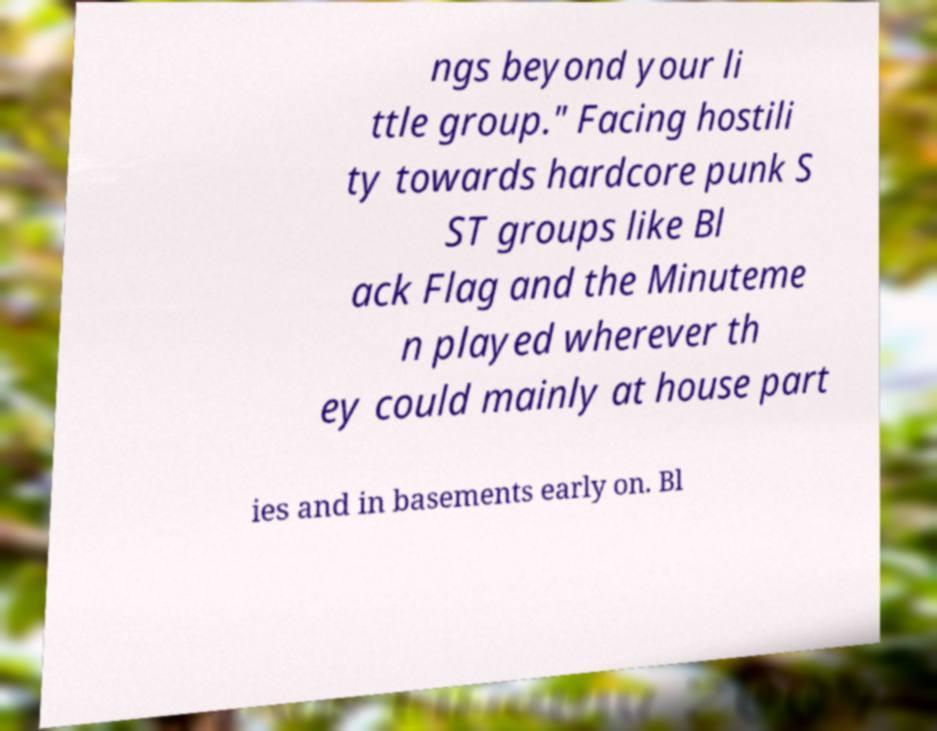Can you read and provide the text displayed in the image?This photo seems to have some interesting text. Can you extract and type it out for me? ngs beyond your li ttle group." Facing hostili ty towards hardcore punk S ST groups like Bl ack Flag and the Minuteme n played wherever th ey could mainly at house part ies and in basements early on. Bl 